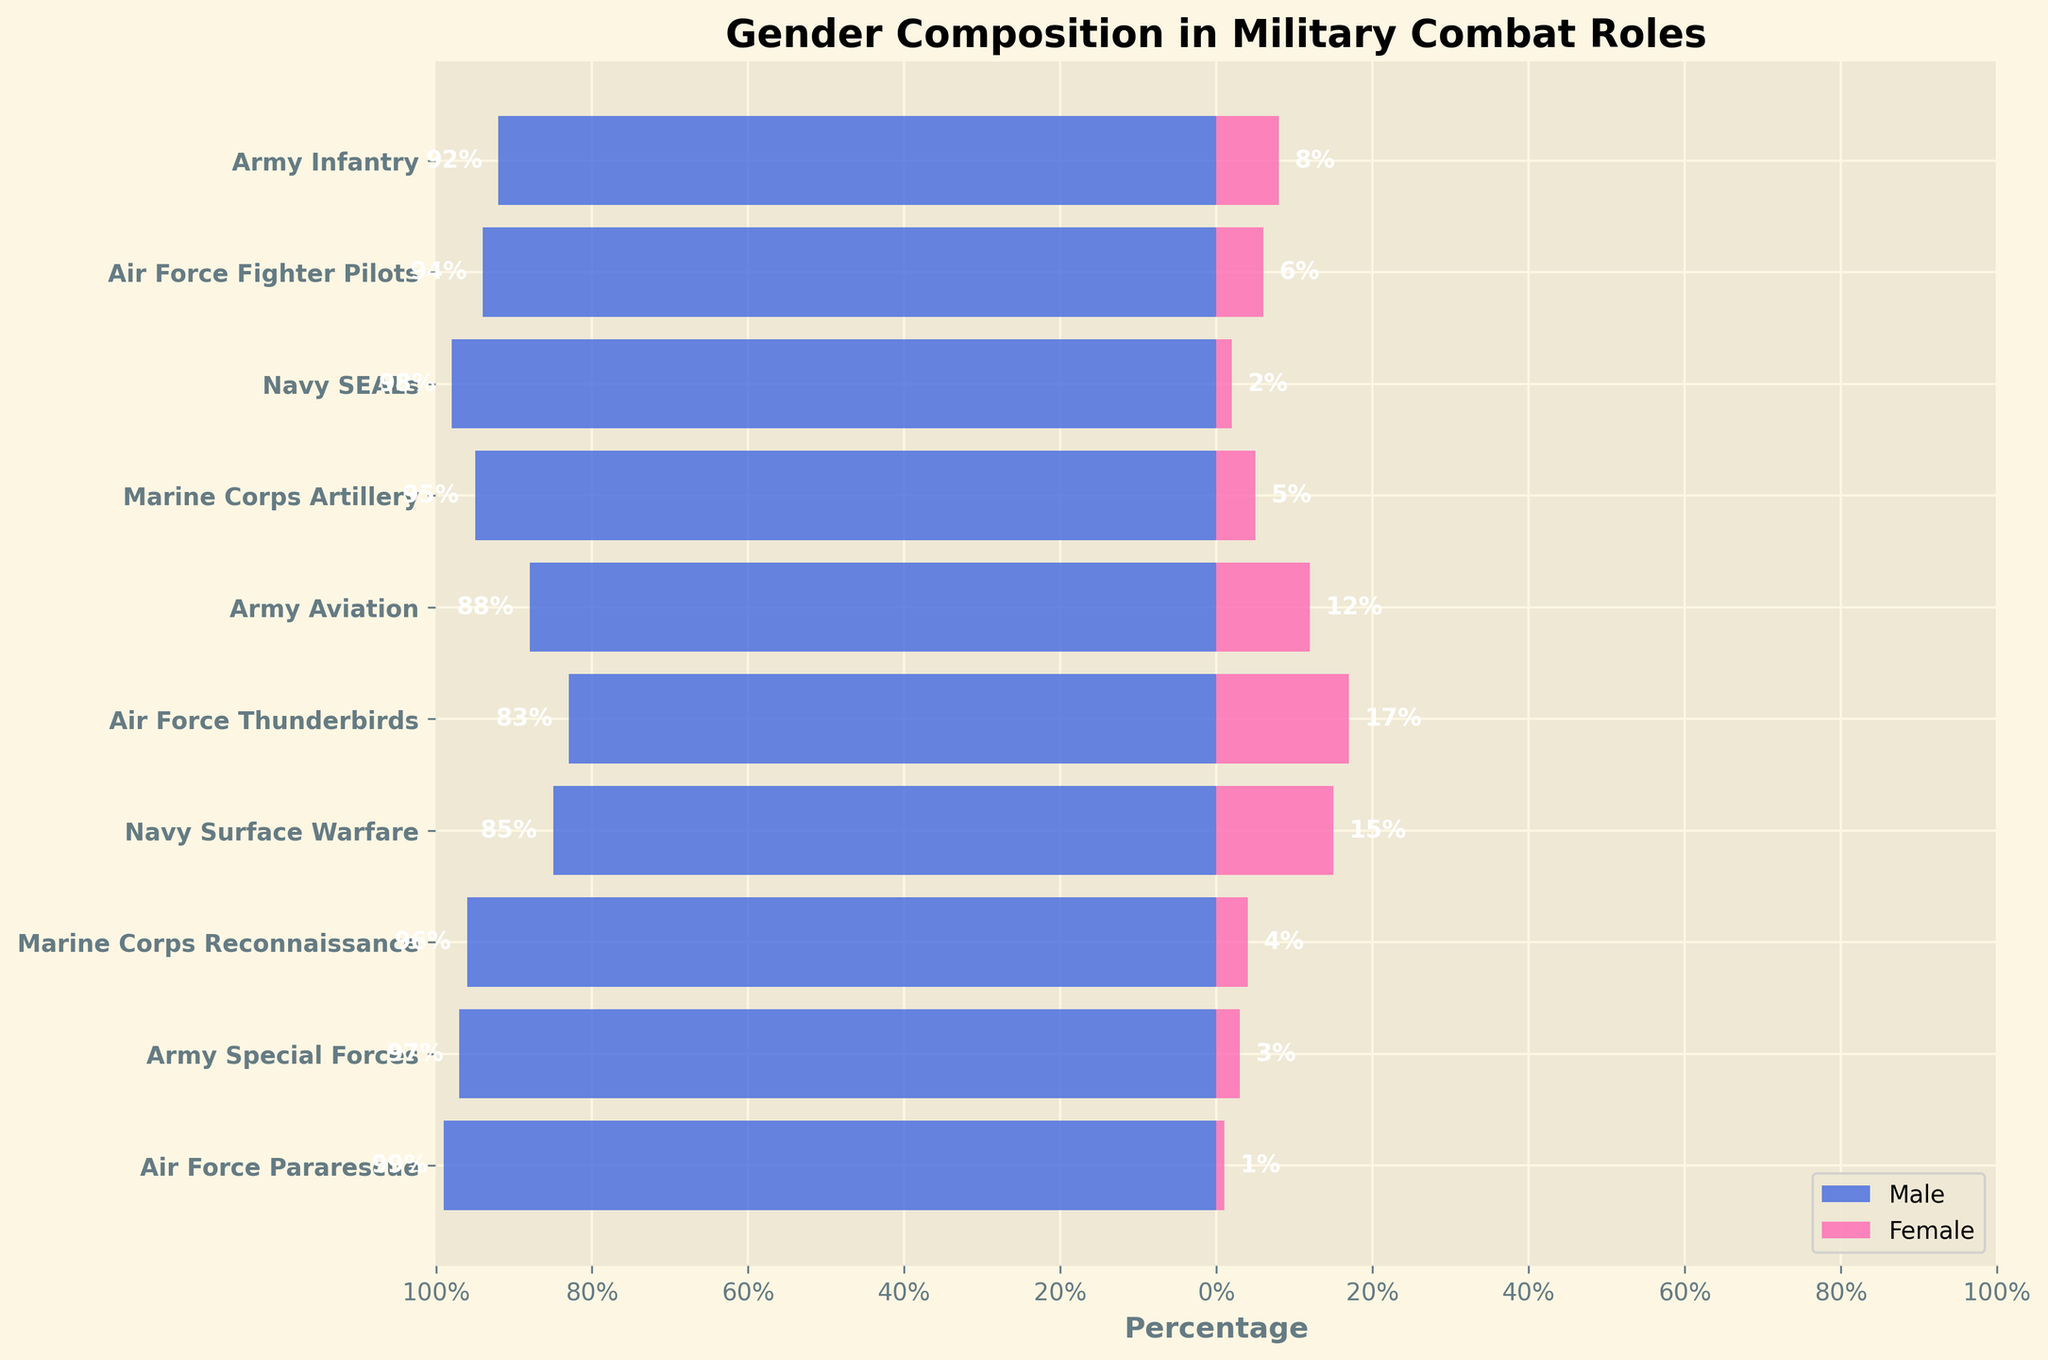Which branch has the highest percentage of female personnel in combat roles? The highest percentage of females can be found by examining the female data bars in the figure. The bar for the Air Force Thunderbirds extends the farthest to the right (17%), indicating it has the highest female composition.
Answer: Air Force Thunderbirds What's the total percentage of males in Navy SEALs and Army Infantry combined? Sum the percentage of males in Navy SEALs (98%) and Army Infantry (92%). So, 98 + 92 = 190.
Answer: 190 Which branch has the smallest difference in percentage between male and female personnel? Calculate the difference for each branch by subtracting the female percentage from the male percentage. The smallest difference is seen in the Air Force Thunderbirds (83% - 17% = 66%).
Answer: Air Force Thunderbirds Compare the percentage of females in Army Aviation and Navy Surface Warfare. Which branch has more females? The percentage of females in Army Aviation is 12%, while in Navy Surface Warfare it is 15%. Hence, Navy Surface Warfare has more females.
Answer: Navy Surface Warfare What is the average percentage of male personnel across all branches? To find the average, add the male percentages for all branches and divide by the number of branches: (92 + 94 + 98 + 95 + 88 + 83 + 85 + 96 + 97 + 99) /10 = 92.7.
Answer: 92.7 In which branch is the gender gap the most pronounced? The gender gap can be determined by looking for the branch with the largest percentage difference between male and female personnel. Air Force Pararescue has the largest difference with 99% males and 1% females, resulting in a 98% gap.
Answer: Air Force Pararescue How many branches have a female composition of 5% or less? Identify the branches where the female composition bar does not extend beyond 5%. These are Navy SEALs (2%), Marine Corps Reconnaissance (4%), Army Special Forces (3%), and Air Force Pararescue (1%). There are 4 such branches.
Answer: 4 Is there any branch where female personnel constitute exactly 10%? Examine the bars to see if any female bar extends exactly to 10%. No bar meets this criterion.
Answer: No Compare the percentage of females in Marine Corps Reconnaissance and Marine Corps Artillery. Which has fewer females? Marine Corps Reconnaissance has 4% females, while Marine Corps Artillery has 5%. Marine Corps Reconnaissance has fewer females.
Answer: Marine Corps Reconnaissance Which branch reflects the closest gender parity (least male-female difference)? Calculate the male-female difference for each branch. The Air Force Thunderbirds, with a difference of 66%, reflect the closest gender parity among the branches.
Answer: Air Force Thunderbirds 